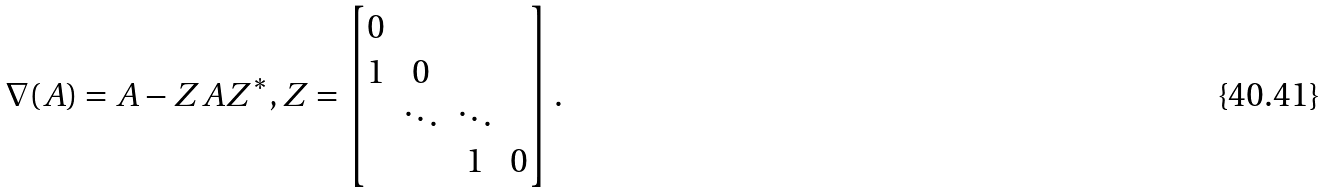<formula> <loc_0><loc_0><loc_500><loc_500>\nabla ( A ) = A - Z A Z ^ { * } , Z = \begin{bmatrix} 0 & \\ 1 & 0 & \\ & \ddots & \ddots \\ & & 1 & 0 \end{bmatrix} .</formula> 